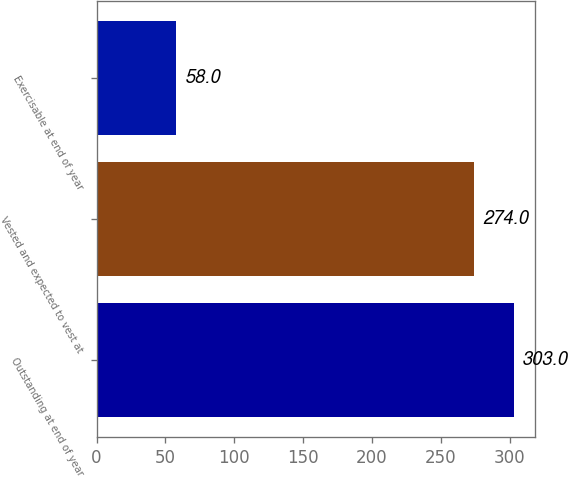<chart> <loc_0><loc_0><loc_500><loc_500><bar_chart><fcel>Outstanding at end of year<fcel>Vested and expected to vest at<fcel>Exercisable at end of year<nl><fcel>303<fcel>274<fcel>58<nl></chart> 